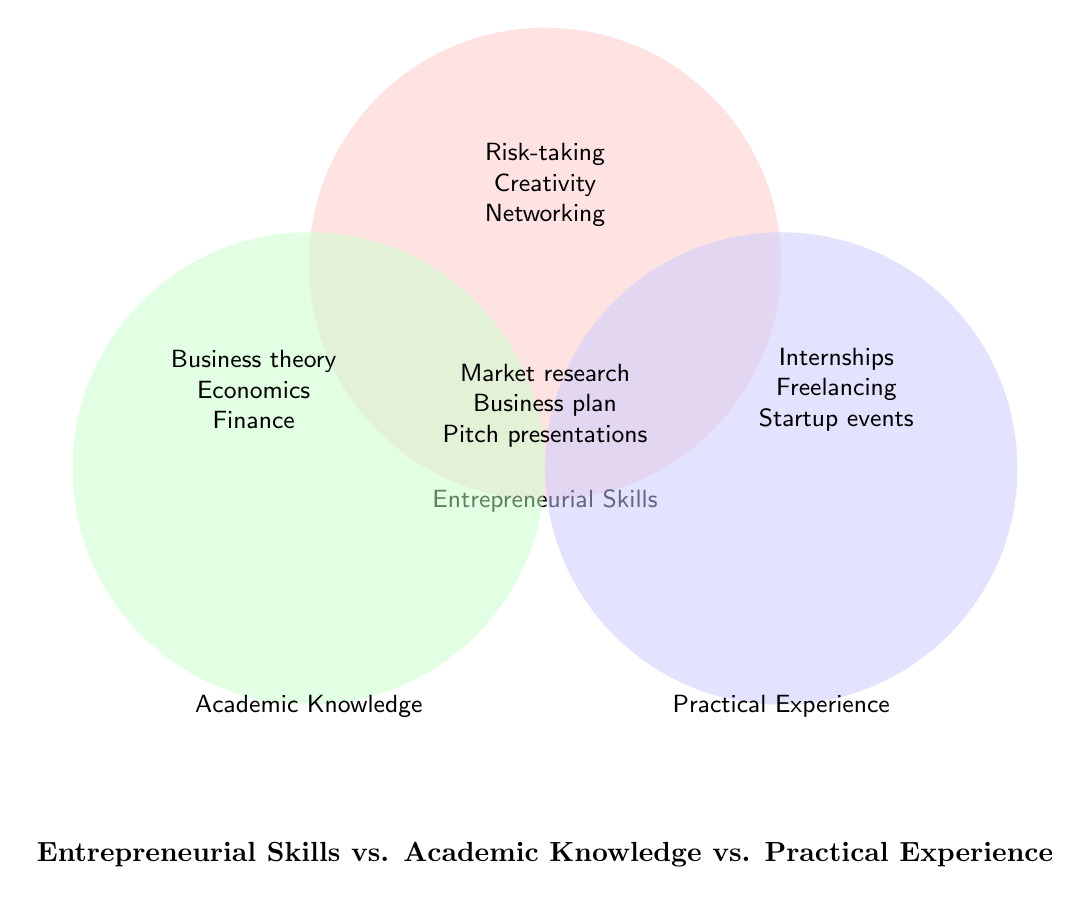What's the color used for Entrepreneurial Skills? The section representing Entrepreneurial Skills is shaded in a light red color.
Answer: Light red What skills are common to Entrepreneurial Skills and Academic Knowledge but not Practical Experience? These skills are listed in the overlapping area between Entrepreneurial Skills and Academic Knowledge but do not fall into the Practical Experience section: Market research, Business plan development.
Answer: Market research, Business plan development Which skills appear only in the Practical Experience section? These skills appear solely in the circle labeled Practical Experience: Internships, Freelancing, Startup events.
Answer: Internships, Freelancing, Startup events Name one skill that overlaps all three areas. The skills in the center section where all three circles overlap include Market research.
Answer: Market research Compare and list the skills under Entrepreneurial Skills and Practical Experience but not Academic Knowledge. The overlapping area between Entrepreneurial Skills and Practical Experience lists Pitch presentations.
Answer: Pitch presentations 